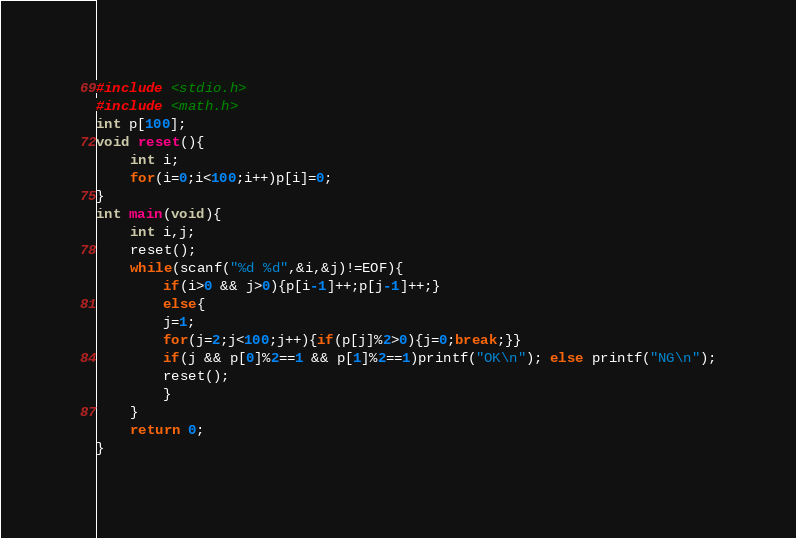Convert code to text. <code><loc_0><loc_0><loc_500><loc_500><_C_>#include <stdio.h>
#include <math.h>
int p[100];
void reset(){
	int i;
	for(i=0;i<100;i++)p[i]=0;
}
int main(void){
	int i,j;
	reset();
	while(scanf("%d %d",&i,&j)!=EOF){
		if(i>0 && j>0){p[i-1]++;p[j-1]++;}
		else{
		j=1;
		for(j=2;j<100;j++){if(p[j]%2>0){j=0;break;}}
		if(j && p[0]%2==1 && p[1]%2==1)printf("OK\n"); else printf("NG\n");
		reset();
		}
	}
	return 0;
}</code> 